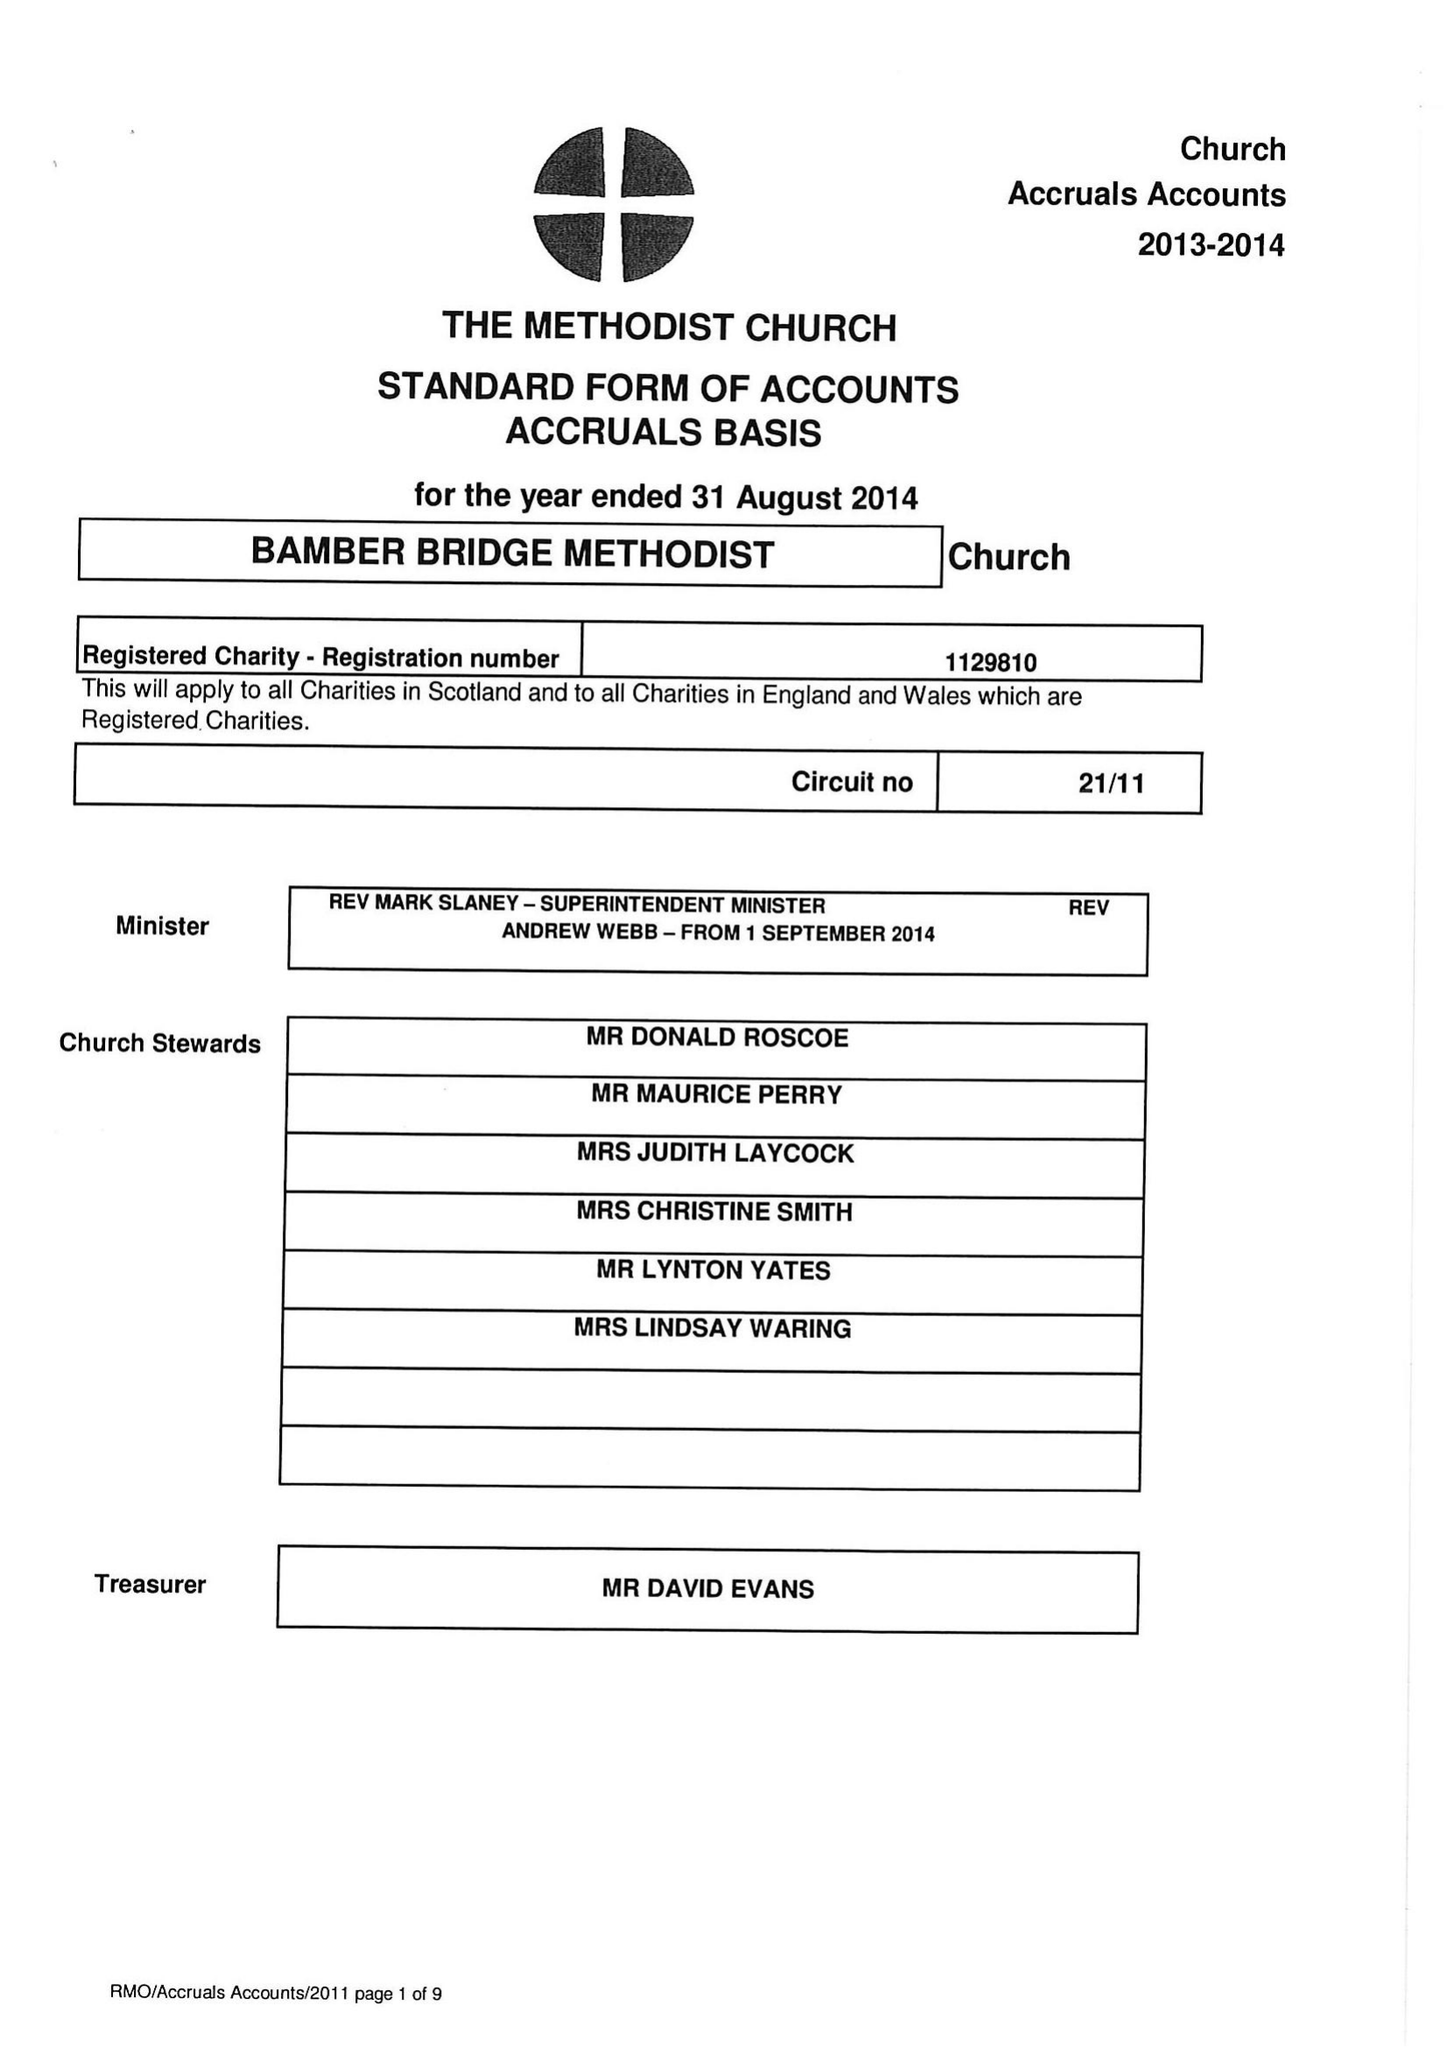What is the value for the report_date?
Answer the question using a single word or phrase. 2014-08-31 